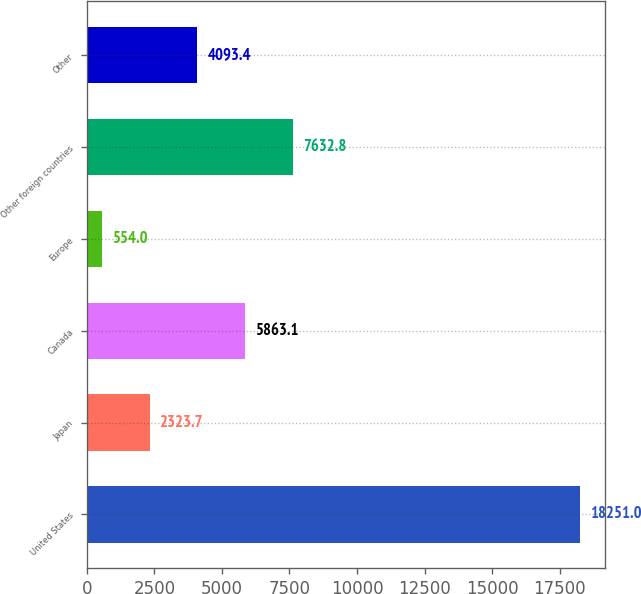<chart> <loc_0><loc_0><loc_500><loc_500><bar_chart><fcel>United States<fcel>Japan<fcel>Canada<fcel>Europe<fcel>Other foreign countries<fcel>Other<nl><fcel>18251<fcel>2323.7<fcel>5863.1<fcel>554<fcel>7632.8<fcel>4093.4<nl></chart> 